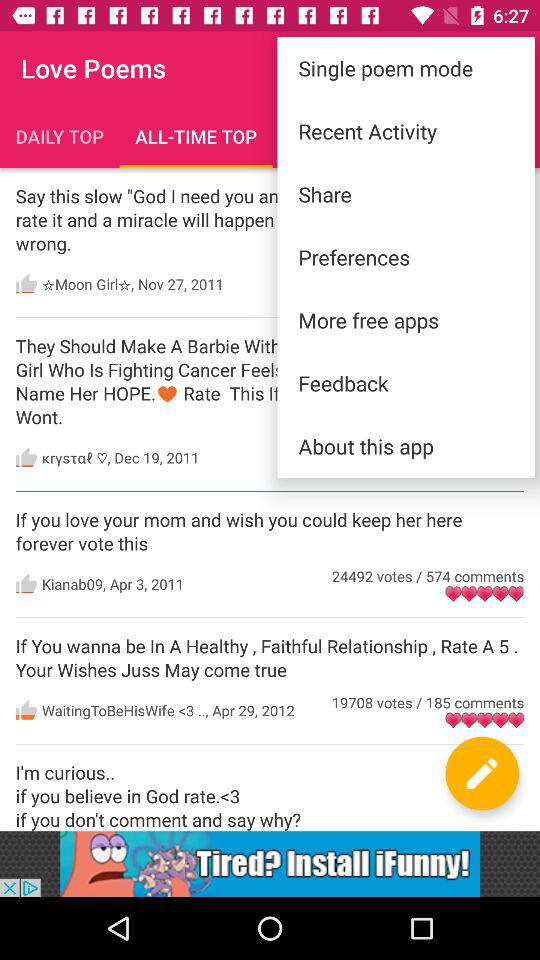What's the count of comments on the "Kianab09" poem? There are 574 comments. 